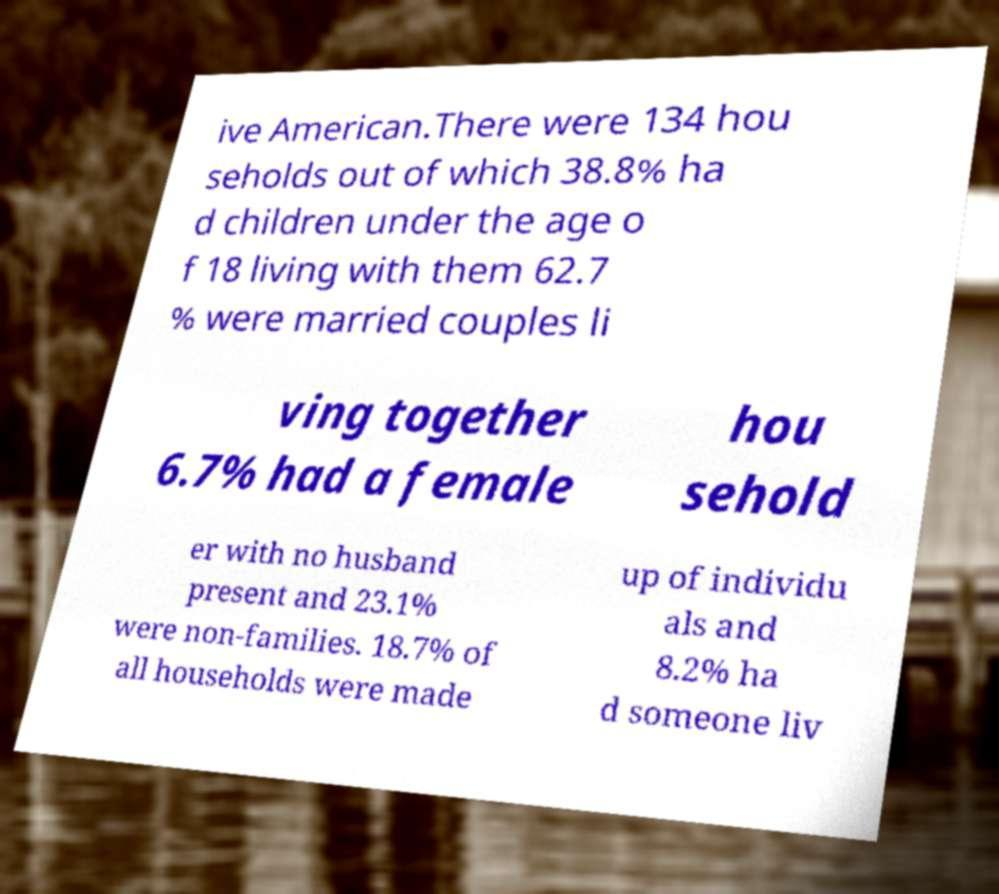What messages or text are displayed in this image? I need them in a readable, typed format. ive American.There were 134 hou seholds out of which 38.8% ha d children under the age o f 18 living with them 62.7 % were married couples li ving together 6.7% had a female hou sehold er with no husband present and 23.1% were non-families. 18.7% of all households were made up of individu als and 8.2% ha d someone liv 